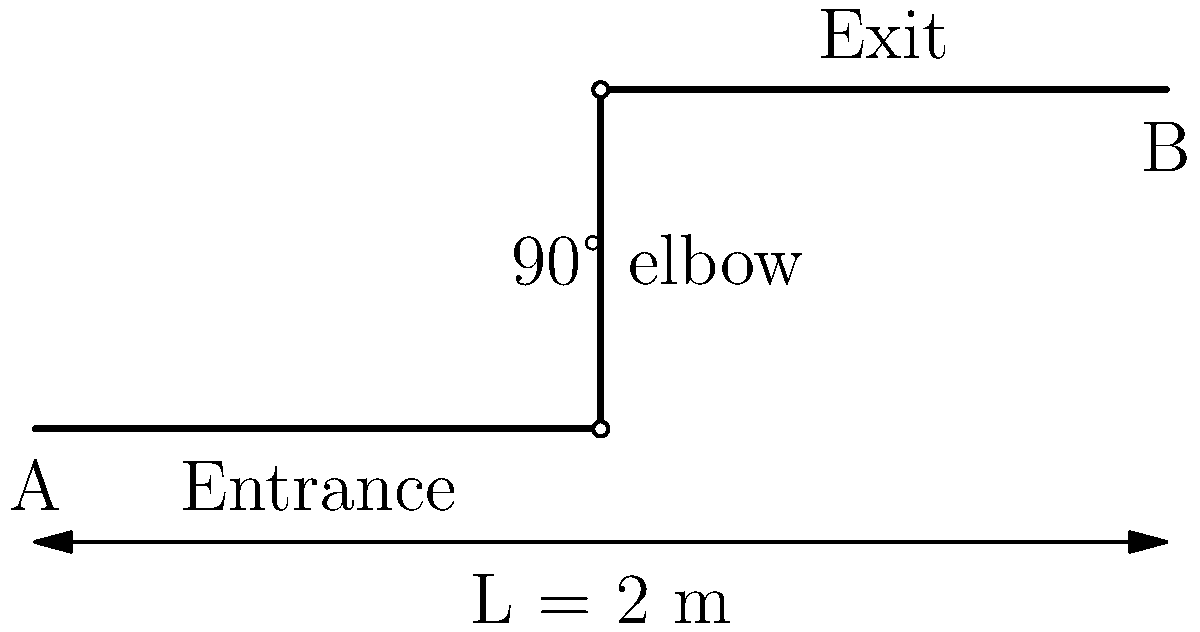A smooth pipe with a diameter of 5 cm and a total length of 2 m has a 90° elbow fitting as shown in the diagram. Water flows through the pipe at a rate of 0.02 m³/s. Calculate the total pressure drop in the pipe system, given that the friction factor $f = 0.02$ and the loss coefficient for the elbow $K_L = 0.3$. Assume the density of water $\rho = 1000$ kg/m³. To calculate the total pressure drop, we need to consider both the friction losses in the pipe and the minor losses due to the elbow fitting. Let's approach this step-by-step:

1. Calculate the flow velocity:
   $V = \frac{Q}{A} = \frac{0.02 \text{ m}³/\text{s}}{\pi (0.025 \text{ m})²} = 10.19 \text{ m/s}$

2. Calculate the friction losses using the Darcy-Weisbach equation:
   $h_f = f \frac{L}{D} \frac{V²}{2g}$
   $h_f = 0.02 \times \frac{2 \text{ m}}{0.05 \text{ m}} \times \frac{(10.19 \text{ m/s})²}{2 \times 9.81 \text{ m/s}²} = 4.22 \text{ m}$

3. Calculate the minor losses due to the elbow:
   $h_m = K_L \frac{V²}{2g}$
   $h_m = 0.3 \times \frac{(10.19 \text{ m/s})²}{2 \times 9.81 \text{ m/s}²} = 1.58 \text{ m}$

4. Calculate the total head loss:
   $h_{\text{total}} = h_f + h_m = 4.22 \text{ m} + 1.58 \text{ m} = 5.80 \text{ m}$

5. Convert head loss to pressure drop:
   $\Delta P = \rho g h_{\text{total}}$
   $\Delta P = 1000 \text{ kg/m}³ \times 9.81 \text{ m/s}² \times 5.80 \text{ m} = 56,898 \text{ Pa}$

Therefore, the total pressure drop in the pipe system is approximately 56.9 kPa.
Answer: 56.9 kPa 